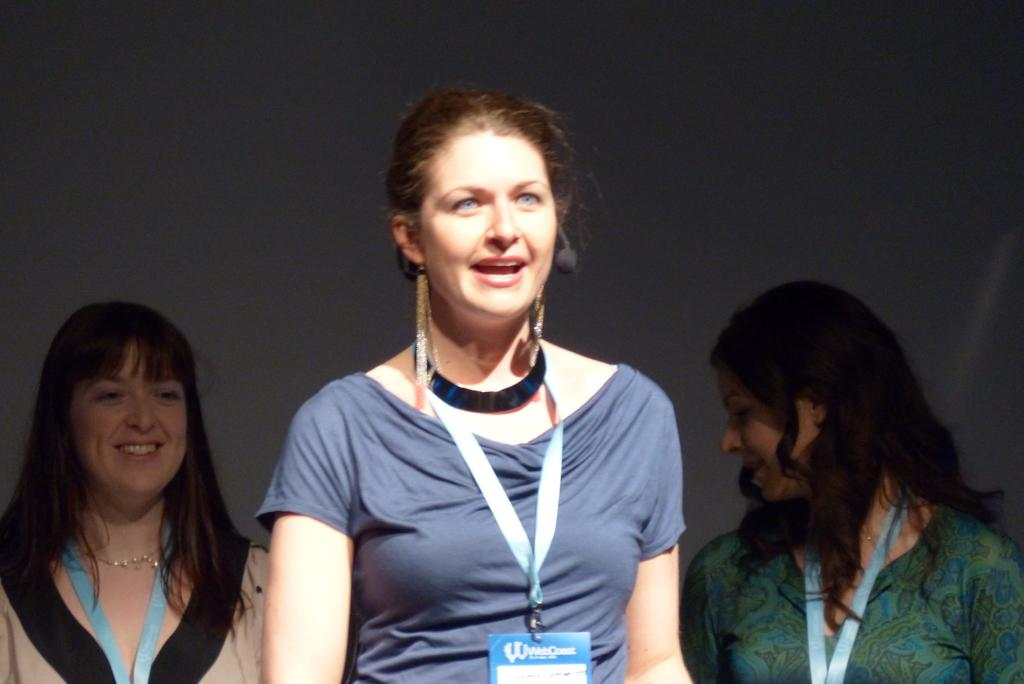What is the main subject of the image? There is a person standing in the image. Can you describe the person's appearance? The person is wearing long earrings and a t-shirt. Does the person have any identification in the image? Yes, the person has an ID card. Are there any other people in the image? Yes, there are two other women standing behind the person. What type of cherry is being used as a comb in the image? There is no cherry or comb present in the image. 